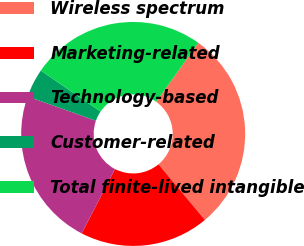Convert chart to OTSL. <chart><loc_0><loc_0><loc_500><loc_500><pie_chart><fcel>Wireless spectrum<fcel>Marketing-related<fcel>Technology-based<fcel>Customer-related<fcel>Total finite-lived intangible<nl><fcel>29.05%<fcel>18.67%<fcel>22.82%<fcel>4.15%<fcel>25.31%<nl></chart> 